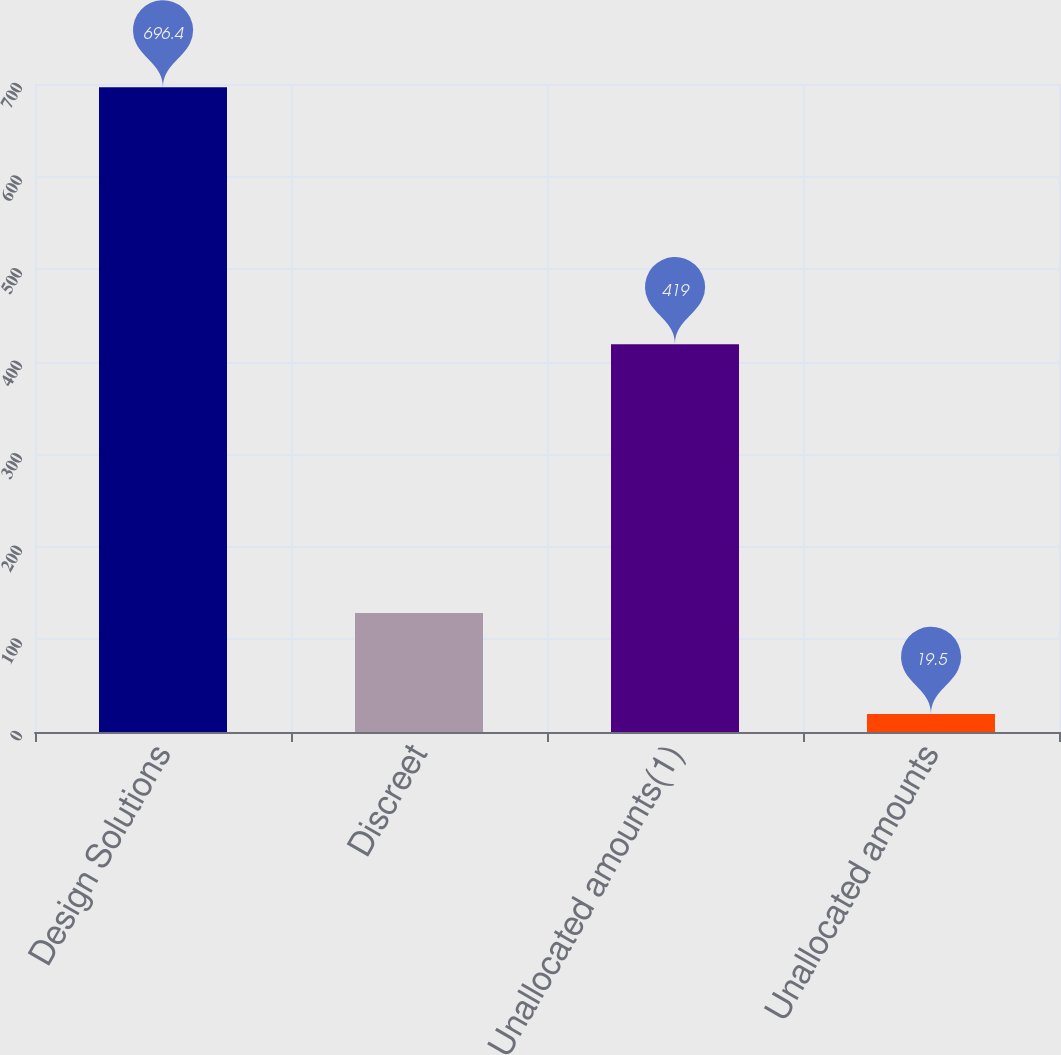<chart> <loc_0><loc_0><loc_500><loc_500><bar_chart><fcel>Design Solutions<fcel>Discreet<fcel>Unallocated amounts(1)<fcel>Unallocated amounts<nl><fcel>696.4<fcel>128.5<fcel>419<fcel>19.5<nl></chart> 